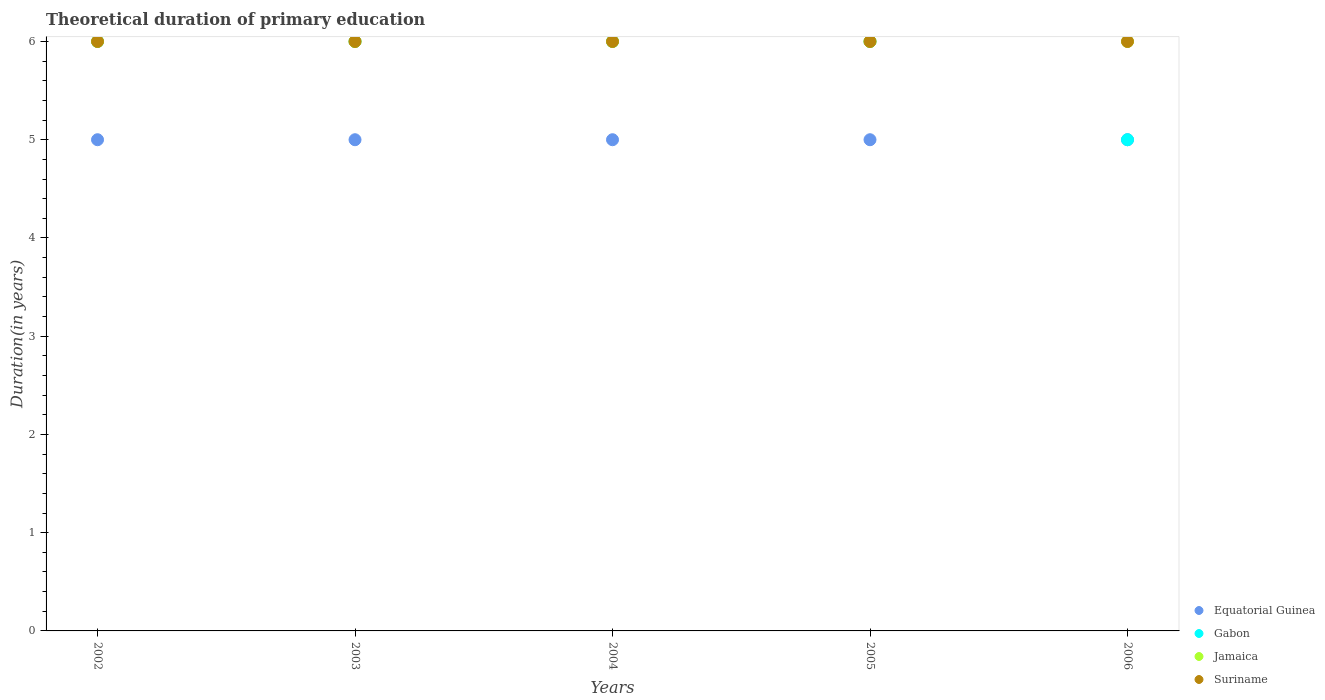How many different coloured dotlines are there?
Give a very brief answer. 4. Is the number of dotlines equal to the number of legend labels?
Ensure brevity in your answer.  Yes. Across all years, what is the maximum total theoretical duration of primary education in Suriname?
Keep it short and to the point. 6. In which year was the total theoretical duration of primary education in Jamaica maximum?
Give a very brief answer. 2002. In which year was the total theoretical duration of primary education in Equatorial Guinea minimum?
Offer a very short reply. 2002. What is the total total theoretical duration of primary education in Jamaica in the graph?
Give a very brief answer. 30. What is the difference between the total theoretical duration of primary education in Gabon in 2004 and that in 2005?
Keep it short and to the point. 0. What is the difference between the total theoretical duration of primary education in Jamaica in 2004 and the total theoretical duration of primary education in Gabon in 2005?
Keep it short and to the point. 0. In the year 2006, what is the difference between the total theoretical duration of primary education in Suriname and total theoretical duration of primary education in Equatorial Guinea?
Offer a very short reply. 1. In how many years, is the total theoretical duration of primary education in Suriname greater than 5.6 years?
Provide a succinct answer. 5. Is the total theoretical duration of primary education in Equatorial Guinea in 2002 less than that in 2003?
Provide a short and direct response. No. What is the difference between the highest and the second highest total theoretical duration of primary education in Gabon?
Your answer should be very brief. 0. Is it the case that in every year, the sum of the total theoretical duration of primary education in Suriname and total theoretical duration of primary education in Equatorial Guinea  is greater than the sum of total theoretical duration of primary education in Jamaica and total theoretical duration of primary education in Gabon?
Provide a succinct answer. Yes. Is it the case that in every year, the sum of the total theoretical duration of primary education in Suriname and total theoretical duration of primary education in Jamaica  is greater than the total theoretical duration of primary education in Equatorial Guinea?
Your answer should be very brief. Yes. Does the total theoretical duration of primary education in Gabon monotonically increase over the years?
Keep it short and to the point. No. Is the total theoretical duration of primary education in Gabon strictly greater than the total theoretical duration of primary education in Suriname over the years?
Your answer should be compact. No. How many dotlines are there?
Provide a succinct answer. 4. Are the values on the major ticks of Y-axis written in scientific E-notation?
Offer a very short reply. No. Does the graph contain any zero values?
Ensure brevity in your answer.  No. Does the graph contain grids?
Offer a very short reply. No. Where does the legend appear in the graph?
Offer a very short reply. Bottom right. What is the title of the graph?
Your response must be concise. Theoretical duration of primary education. Does "Austria" appear as one of the legend labels in the graph?
Your answer should be very brief. No. What is the label or title of the X-axis?
Give a very brief answer. Years. What is the label or title of the Y-axis?
Your answer should be very brief. Duration(in years). What is the Duration(in years) in Gabon in 2002?
Offer a very short reply. 6. What is the Duration(in years) of Jamaica in 2002?
Ensure brevity in your answer.  6. What is the Duration(in years) in Suriname in 2002?
Give a very brief answer. 6. What is the Duration(in years) of Equatorial Guinea in 2004?
Offer a very short reply. 5. What is the Duration(in years) in Gabon in 2004?
Provide a short and direct response. 6. What is the Duration(in years) in Suriname in 2004?
Your answer should be very brief. 6. What is the Duration(in years) in Jamaica in 2005?
Ensure brevity in your answer.  6. What is the Duration(in years) in Suriname in 2005?
Your response must be concise. 6. What is the Duration(in years) in Equatorial Guinea in 2006?
Ensure brevity in your answer.  5. What is the Duration(in years) in Jamaica in 2006?
Ensure brevity in your answer.  6. Across all years, what is the maximum Duration(in years) in Equatorial Guinea?
Ensure brevity in your answer.  5. Across all years, what is the maximum Duration(in years) in Gabon?
Make the answer very short. 6. Across all years, what is the maximum Duration(in years) of Suriname?
Offer a very short reply. 6. Across all years, what is the minimum Duration(in years) in Equatorial Guinea?
Provide a succinct answer. 5. What is the total Duration(in years) in Gabon in the graph?
Give a very brief answer. 29. What is the difference between the Duration(in years) of Suriname in 2002 and that in 2003?
Your answer should be very brief. 0. What is the difference between the Duration(in years) in Jamaica in 2002 and that in 2004?
Your answer should be very brief. 0. What is the difference between the Duration(in years) in Suriname in 2002 and that in 2004?
Ensure brevity in your answer.  0. What is the difference between the Duration(in years) of Equatorial Guinea in 2002 and that in 2005?
Offer a terse response. 0. What is the difference between the Duration(in years) of Suriname in 2002 and that in 2006?
Give a very brief answer. 0. What is the difference between the Duration(in years) of Gabon in 2003 and that in 2004?
Make the answer very short. 0. What is the difference between the Duration(in years) of Jamaica in 2003 and that in 2004?
Provide a short and direct response. 0. What is the difference between the Duration(in years) in Suriname in 2003 and that in 2004?
Keep it short and to the point. 0. What is the difference between the Duration(in years) of Gabon in 2003 and that in 2006?
Provide a short and direct response. 1. What is the difference between the Duration(in years) in Jamaica in 2003 and that in 2006?
Provide a succinct answer. 0. What is the difference between the Duration(in years) in Equatorial Guinea in 2004 and that in 2006?
Ensure brevity in your answer.  0. What is the difference between the Duration(in years) in Gabon in 2004 and that in 2006?
Ensure brevity in your answer.  1. What is the difference between the Duration(in years) of Equatorial Guinea in 2005 and that in 2006?
Your response must be concise. 0. What is the difference between the Duration(in years) of Gabon in 2005 and that in 2006?
Your answer should be very brief. 1. What is the difference between the Duration(in years) of Suriname in 2005 and that in 2006?
Make the answer very short. 0. What is the difference between the Duration(in years) in Equatorial Guinea in 2002 and the Duration(in years) in Jamaica in 2003?
Keep it short and to the point. -1. What is the difference between the Duration(in years) of Gabon in 2002 and the Duration(in years) of Jamaica in 2003?
Your answer should be compact. 0. What is the difference between the Duration(in years) of Gabon in 2002 and the Duration(in years) of Suriname in 2003?
Ensure brevity in your answer.  0. What is the difference between the Duration(in years) of Equatorial Guinea in 2002 and the Duration(in years) of Gabon in 2004?
Give a very brief answer. -1. What is the difference between the Duration(in years) in Equatorial Guinea in 2002 and the Duration(in years) in Suriname in 2004?
Keep it short and to the point. -1. What is the difference between the Duration(in years) of Gabon in 2002 and the Duration(in years) of Jamaica in 2004?
Offer a very short reply. 0. What is the difference between the Duration(in years) in Gabon in 2002 and the Duration(in years) in Suriname in 2004?
Your answer should be very brief. 0. What is the difference between the Duration(in years) of Equatorial Guinea in 2002 and the Duration(in years) of Gabon in 2005?
Provide a succinct answer. -1. What is the difference between the Duration(in years) of Equatorial Guinea in 2002 and the Duration(in years) of Jamaica in 2005?
Provide a short and direct response. -1. What is the difference between the Duration(in years) in Equatorial Guinea in 2002 and the Duration(in years) in Suriname in 2005?
Give a very brief answer. -1. What is the difference between the Duration(in years) in Equatorial Guinea in 2002 and the Duration(in years) in Gabon in 2006?
Give a very brief answer. 0. What is the difference between the Duration(in years) in Equatorial Guinea in 2002 and the Duration(in years) in Jamaica in 2006?
Make the answer very short. -1. What is the difference between the Duration(in years) in Equatorial Guinea in 2002 and the Duration(in years) in Suriname in 2006?
Keep it short and to the point. -1. What is the difference between the Duration(in years) in Gabon in 2002 and the Duration(in years) in Jamaica in 2006?
Ensure brevity in your answer.  0. What is the difference between the Duration(in years) of Gabon in 2002 and the Duration(in years) of Suriname in 2006?
Keep it short and to the point. 0. What is the difference between the Duration(in years) in Jamaica in 2002 and the Duration(in years) in Suriname in 2006?
Make the answer very short. 0. What is the difference between the Duration(in years) in Equatorial Guinea in 2003 and the Duration(in years) in Jamaica in 2005?
Your answer should be compact. -1. What is the difference between the Duration(in years) in Gabon in 2003 and the Duration(in years) in Jamaica in 2005?
Ensure brevity in your answer.  0. What is the difference between the Duration(in years) of Gabon in 2003 and the Duration(in years) of Suriname in 2005?
Your answer should be very brief. 0. What is the difference between the Duration(in years) of Equatorial Guinea in 2003 and the Duration(in years) of Gabon in 2006?
Ensure brevity in your answer.  0. What is the difference between the Duration(in years) of Equatorial Guinea in 2003 and the Duration(in years) of Jamaica in 2006?
Your answer should be compact. -1. What is the difference between the Duration(in years) of Gabon in 2003 and the Duration(in years) of Suriname in 2006?
Provide a short and direct response. 0. What is the difference between the Duration(in years) of Jamaica in 2003 and the Duration(in years) of Suriname in 2006?
Provide a short and direct response. 0. What is the difference between the Duration(in years) of Equatorial Guinea in 2004 and the Duration(in years) of Jamaica in 2005?
Keep it short and to the point. -1. What is the difference between the Duration(in years) in Jamaica in 2004 and the Duration(in years) in Suriname in 2005?
Provide a succinct answer. 0. What is the difference between the Duration(in years) in Equatorial Guinea in 2004 and the Duration(in years) in Suriname in 2006?
Give a very brief answer. -1. What is the difference between the Duration(in years) in Jamaica in 2004 and the Duration(in years) in Suriname in 2006?
Make the answer very short. 0. What is the difference between the Duration(in years) of Equatorial Guinea in 2005 and the Duration(in years) of Gabon in 2006?
Provide a short and direct response. 0. What is the difference between the Duration(in years) of Equatorial Guinea in 2005 and the Duration(in years) of Suriname in 2006?
Offer a very short reply. -1. What is the difference between the Duration(in years) in Gabon in 2005 and the Duration(in years) in Suriname in 2006?
Your answer should be very brief. 0. What is the average Duration(in years) of Gabon per year?
Your response must be concise. 5.8. What is the average Duration(in years) in Jamaica per year?
Provide a short and direct response. 6. In the year 2002, what is the difference between the Duration(in years) in Equatorial Guinea and Duration(in years) in Gabon?
Your response must be concise. -1. In the year 2002, what is the difference between the Duration(in years) of Equatorial Guinea and Duration(in years) of Jamaica?
Your answer should be very brief. -1. In the year 2002, what is the difference between the Duration(in years) in Gabon and Duration(in years) in Jamaica?
Keep it short and to the point. 0. In the year 2002, what is the difference between the Duration(in years) in Gabon and Duration(in years) in Suriname?
Provide a succinct answer. 0. In the year 2003, what is the difference between the Duration(in years) of Equatorial Guinea and Duration(in years) of Gabon?
Make the answer very short. -1. In the year 2003, what is the difference between the Duration(in years) in Equatorial Guinea and Duration(in years) in Suriname?
Ensure brevity in your answer.  -1. In the year 2003, what is the difference between the Duration(in years) of Gabon and Duration(in years) of Jamaica?
Your answer should be very brief. 0. In the year 2003, what is the difference between the Duration(in years) in Gabon and Duration(in years) in Suriname?
Keep it short and to the point. 0. In the year 2003, what is the difference between the Duration(in years) of Jamaica and Duration(in years) of Suriname?
Provide a short and direct response. 0. In the year 2004, what is the difference between the Duration(in years) of Gabon and Duration(in years) of Suriname?
Ensure brevity in your answer.  0. In the year 2005, what is the difference between the Duration(in years) in Equatorial Guinea and Duration(in years) in Gabon?
Offer a terse response. -1. In the year 2005, what is the difference between the Duration(in years) of Equatorial Guinea and Duration(in years) of Suriname?
Offer a terse response. -1. In the year 2005, what is the difference between the Duration(in years) of Jamaica and Duration(in years) of Suriname?
Ensure brevity in your answer.  0. In the year 2006, what is the difference between the Duration(in years) of Equatorial Guinea and Duration(in years) of Gabon?
Keep it short and to the point. 0. In the year 2006, what is the difference between the Duration(in years) in Equatorial Guinea and Duration(in years) in Jamaica?
Make the answer very short. -1. In the year 2006, what is the difference between the Duration(in years) in Gabon and Duration(in years) in Jamaica?
Your answer should be compact. -1. In the year 2006, what is the difference between the Duration(in years) of Gabon and Duration(in years) of Suriname?
Give a very brief answer. -1. In the year 2006, what is the difference between the Duration(in years) of Jamaica and Duration(in years) of Suriname?
Ensure brevity in your answer.  0. What is the ratio of the Duration(in years) of Equatorial Guinea in 2002 to that in 2003?
Your response must be concise. 1. What is the ratio of the Duration(in years) of Equatorial Guinea in 2002 to that in 2004?
Ensure brevity in your answer.  1. What is the ratio of the Duration(in years) in Jamaica in 2002 to that in 2004?
Your answer should be very brief. 1. What is the ratio of the Duration(in years) in Equatorial Guinea in 2002 to that in 2005?
Give a very brief answer. 1. What is the ratio of the Duration(in years) of Gabon in 2002 to that in 2005?
Your response must be concise. 1. What is the ratio of the Duration(in years) of Suriname in 2002 to that in 2005?
Your response must be concise. 1. What is the ratio of the Duration(in years) of Equatorial Guinea in 2002 to that in 2006?
Offer a terse response. 1. What is the ratio of the Duration(in years) in Equatorial Guinea in 2003 to that in 2004?
Your response must be concise. 1. What is the ratio of the Duration(in years) of Gabon in 2003 to that in 2004?
Your response must be concise. 1. What is the ratio of the Duration(in years) in Jamaica in 2003 to that in 2004?
Your answer should be compact. 1. What is the ratio of the Duration(in years) in Suriname in 2003 to that in 2004?
Ensure brevity in your answer.  1. What is the ratio of the Duration(in years) of Equatorial Guinea in 2003 to that in 2005?
Offer a very short reply. 1. What is the ratio of the Duration(in years) in Gabon in 2003 to that in 2006?
Your answer should be compact. 1.2. What is the ratio of the Duration(in years) in Gabon in 2004 to that in 2005?
Your answer should be very brief. 1. What is the ratio of the Duration(in years) of Suriname in 2004 to that in 2005?
Keep it short and to the point. 1. What is the ratio of the Duration(in years) of Gabon in 2004 to that in 2006?
Your answer should be compact. 1.2. What is the ratio of the Duration(in years) in Suriname in 2004 to that in 2006?
Give a very brief answer. 1. What is the difference between the highest and the second highest Duration(in years) of Equatorial Guinea?
Provide a succinct answer. 0. What is the difference between the highest and the second highest Duration(in years) of Jamaica?
Provide a short and direct response. 0. What is the difference between the highest and the second highest Duration(in years) in Suriname?
Provide a short and direct response. 0. What is the difference between the highest and the lowest Duration(in years) in Gabon?
Offer a very short reply. 1. What is the difference between the highest and the lowest Duration(in years) of Suriname?
Your answer should be very brief. 0. 